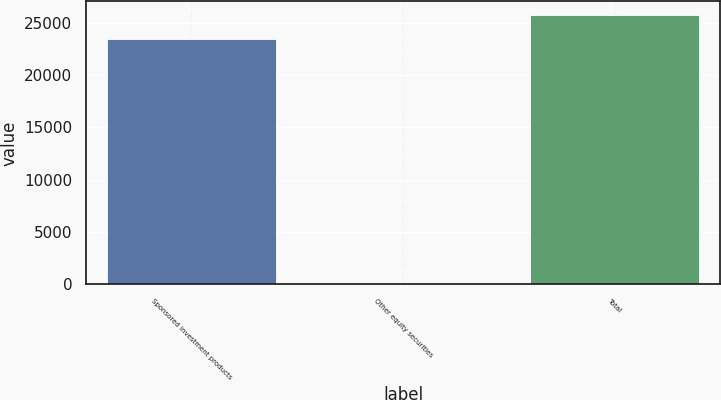Convert chart to OTSL. <chart><loc_0><loc_0><loc_500><loc_500><bar_chart><fcel>Sponsored investment products<fcel>Other equity securities<fcel>Total<nl><fcel>23394<fcel>26<fcel>25733.4<nl></chart> 